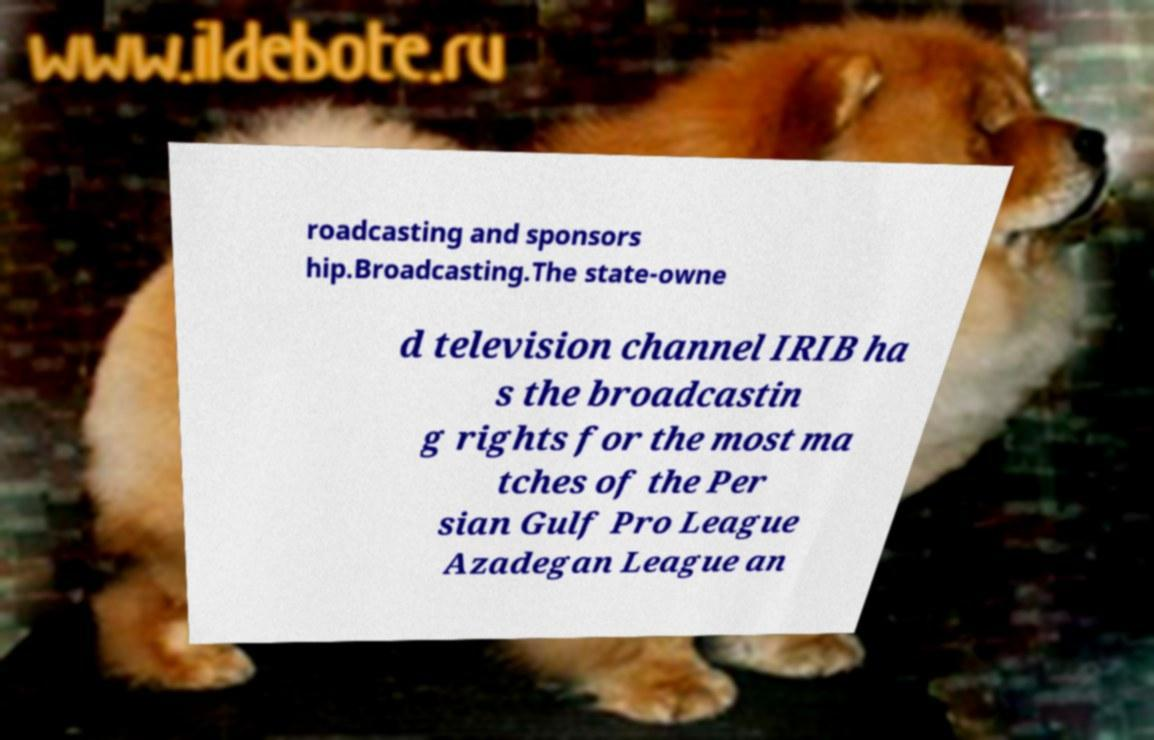Please read and relay the text visible in this image. What does it say? roadcasting and sponsors hip.Broadcasting.The state-owne d television channel IRIB ha s the broadcastin g rights for the most ma tches of the Per sian Gulf Pro League Azadegan League an 